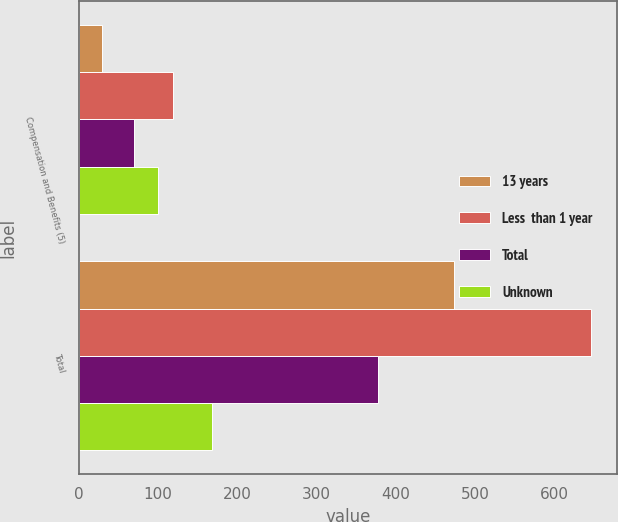<chart> <loc_0><loc_0><loc_500><loc_500><stacked_bar_chart><ecel><fcel>Compensation and Benefits (5)<fcel>Total<nl><fcel>13 years<fcel>29.5<fcel>472.8<nl><fcel>Less  than 1 year<fcel>119.1<fcel>646.4<nl><fcel>Total<fcel>69.7<fcel>377.9<nl><fcel>Unknown<fcel>99.6<fcel>168.2<nl></chart> 